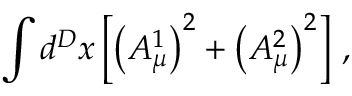Convert formula to latex. <formula><loc_0><loc_0><loc_500><loc_500>\int d ^ { D } x \left [ \left ( A _ { \mu } ^ { 1 } \right ) ^ { 2 } + \left ( A _ { \mu } ^ { 2 } \right ) ^ { 2 } \right ] \, ,</formula> 